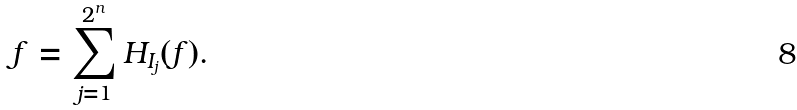<formula> <loc_0><loc_0><loc_500><loc_500>f = \sum _ { j = 1 } ^ { 2 ^ { n } } H _ { I _ { j } } ( f ) .</formula> 